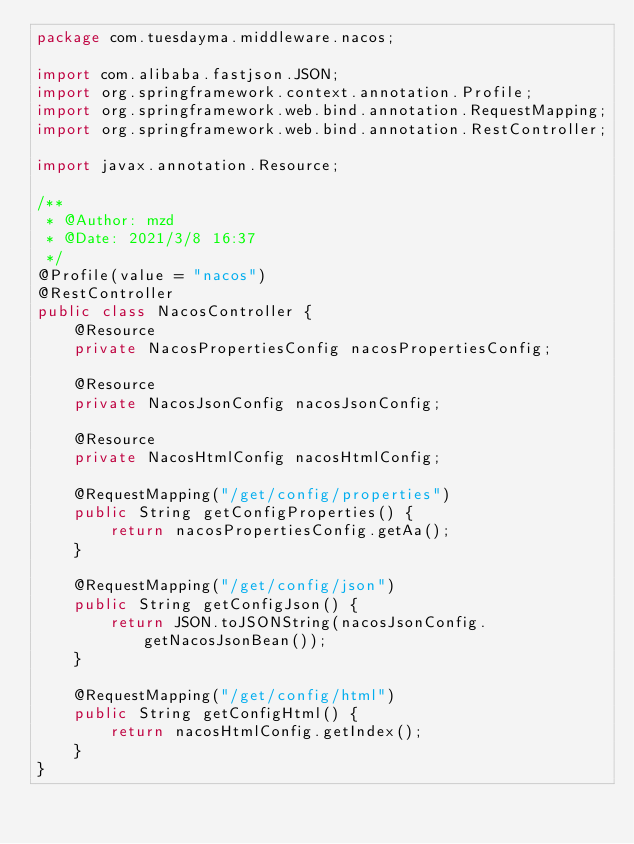<code> <loc_0><loc_0><loc_500><loc_500><_Java_>package com.tuesdayma.middleware.nacos;

import com.alibaba.fastjson.JSON;
import org.springframework.context.annotation.Profile;
import org.springframework.web.bind.annotation.RequestMapping;
import org.springframework.web.bind.annotation.RestController;

import javax.annotation.Resource;

/**
 * @Author: mzd
 * @Date: 2021/3/8 16:37
 */
@Profile(value = "nacos")
@RestController
public class NacosController {
    @Resource
    private NacosPropertiesConfig nacosPropertiesConfig;

    @Resource
    private NacosJsonConfig nacosJsonConfig;

    @Resource
    private NacosHtmlConfig nacosHtmlConfig;

    @RequestMapping("/get/config/properties")
    public String getConfigProperties() {
        return nacosPropertiesConfig.getAa();
    }

    @RequestMapping("/get/config/json")
    public String getConfigJson() {
        return JSON.toJSONString(nacosJsonConfig.getNacosJsonBean());
    }

    @RequestMapping("/get/config/html")
    public String getConfigHtml() {
        return nacosHtmlConfig.getIndex();
    }
}
</code> 